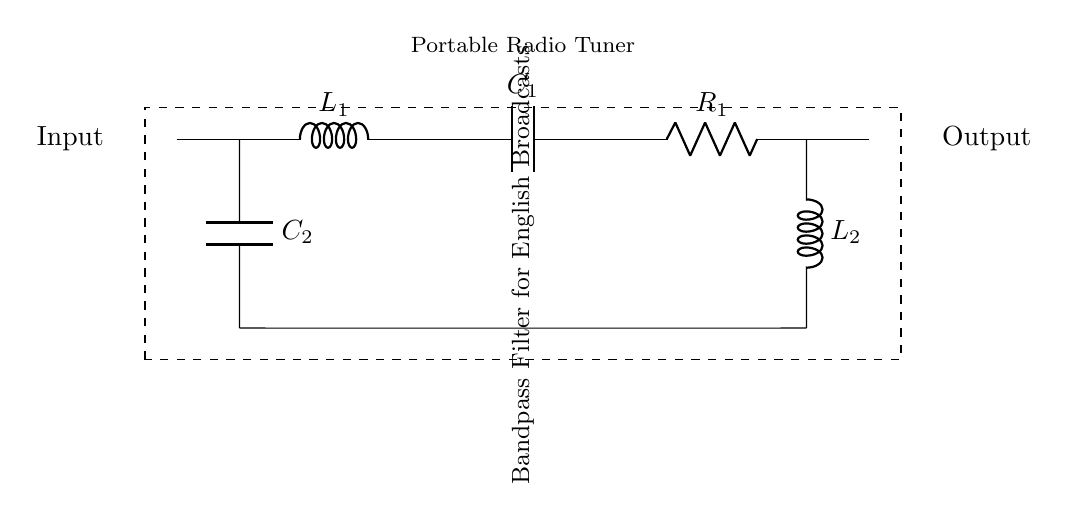What types of components are used in this circuit? The circuit includes an inductor (L), capacitors (C), and a resistor (R). Specifically, it features two inductors, two capacitors, and one resistor labeled L1, C1, C2, R1, and L2.
Answer: inductor, capacitor, resistor What is the purpose of this circuit? The circuit is labeled as a bandpass filter, which means its purpose is to allow signals within a certain frequency range to pass while blocking those outside that range. This is useful for tuning into specific broadcasts, like English language programs.
Answer: bandpass filter How many capacitors are present in the circuit? There are two capacitors labeled C1 and C2 in the circuit, as indicated by their respective notations.
Answer: two What is the configuration of the components? The two capacitors are arranged in parallel, while the inductor and resistor are in series with the entire combination. This configuration is typical for a bandpass filter where specific frequency selection is required.
Answer: parallel and series What is the significance of the label "Input" and "Output"? The "Input" label denotes where the signal enters the circuit, while the "Output" label indicates where the filtered signal exits. This helps in understanding the flow of the signal through the bandpass filter.
Answer: signal flow Which component typically dominates the frequency response in this circuit? The capacitors and inductors control the frequency response, but in a bandpass filter arrangement, the inductors generally play a crucial role in determining the cutoff frequency, especially at lower frequencies.
Answer: inductors What is the function of the resistor in this circuit? The resistor helps to limit the current and can affect the quality factor (Q) of the filter, influencing its selectivity and bandwidth. This ensures that the circuit can manage power dissipation effectively.
Answer: current limiter 